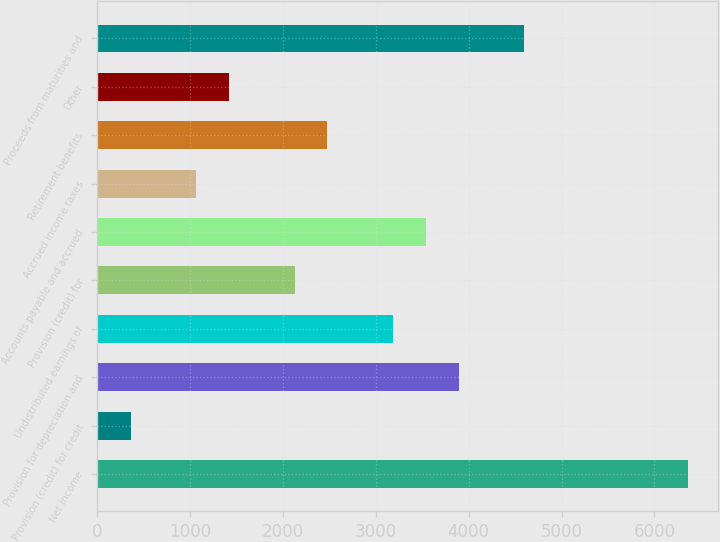<chart> <loc_0><loc_0><loc_500><loc_500><bar_chart><fcel>Net income<fcel>Provision (credit) for credit<fcel>Provision for depreciation and<fcel>Undistributed earnings of<fcel>Provision (credit) for<fcel>Accounts payable and accrued<fcel>Accrued income taxes<fcel>Retirement benefits<fcel>Other<fcel>Proceeds from maturities and<nl><fcel>6363.36<fcel>358.62<fcel>3890.82<fcel>3184.38<fcel>2124.72<fcel>3537.6<fcel>1065.06<fcel>2477.94<fcel>1418.28<fcel>4597.26<nl></chart> 